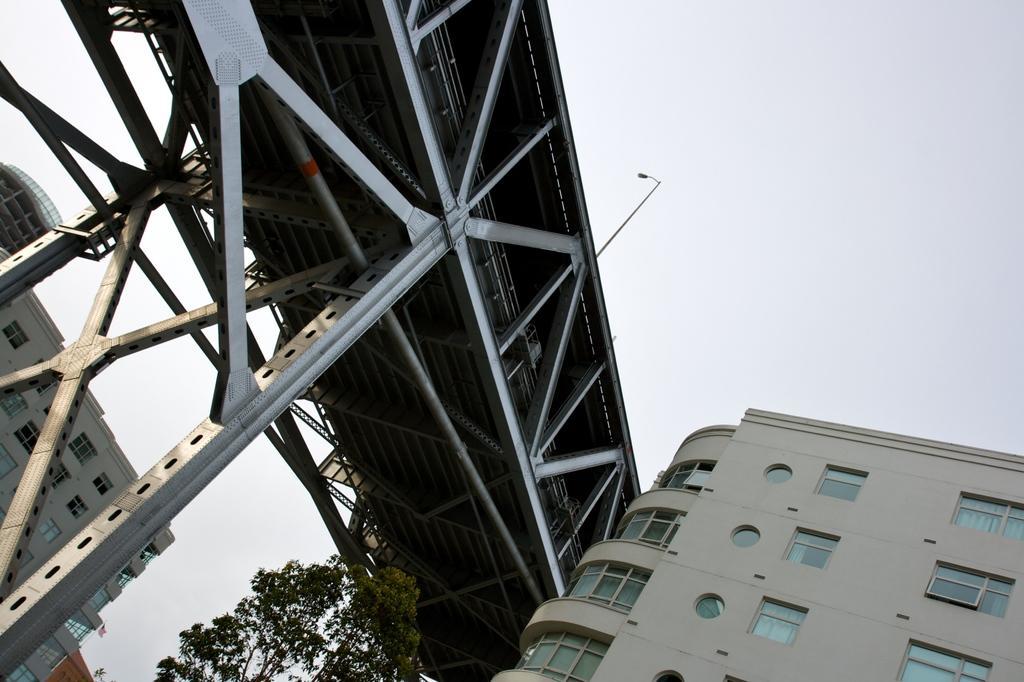Describe this image in one or two sentences. There are buildings with the windows, This is bridge, tree and a sky. 